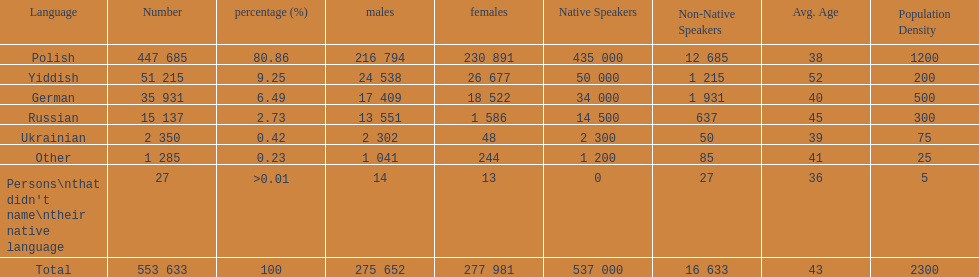How many languages have a name that is derived from a country? 4. 